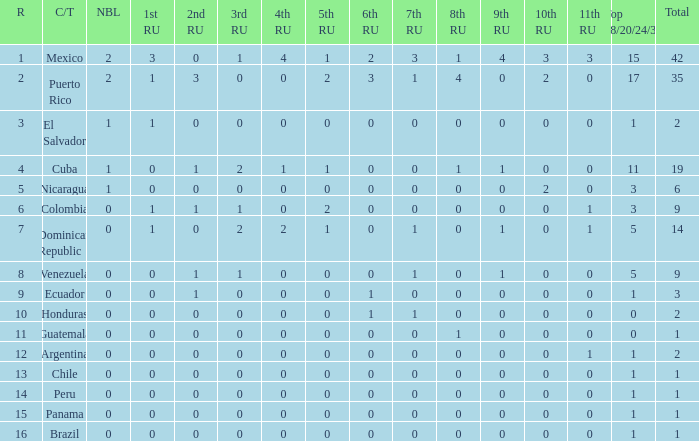What is the lowest 7th runner-up of the country with a top 18/20/24/30 greater than 5, a 1st runner-up greater than 0, and an 11th runner-up less than 0? None. 